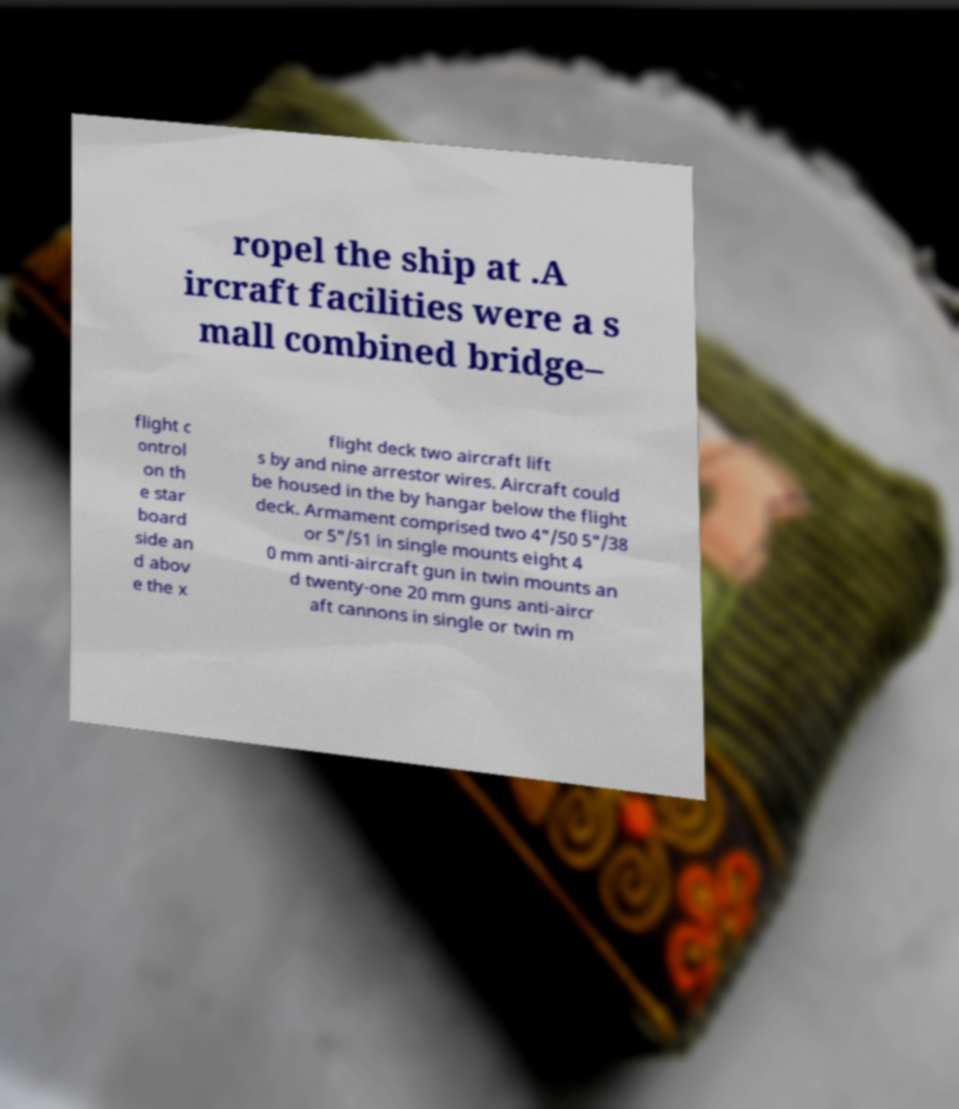Can you read and provide the text displayed in the image?This photo seems to have some interesting text. Can you extract and type it out for me? ropel the ship at .A ircraft facilities were a s mall combined bridge– flight c ontrol on th e star board side an d abov e the x flight deck two aircraft lift s by and nine arrestor wires. Aircraft could be housed in the by hangar below the flight deck. Armament comprised two 4"/50 5"/38 or 5"/51 in single mounts eight 4 0 mm anti-aircraft gun in twin mounts an d twenty-one 20 mm guns anti-aircr aft cannons in single or twin m 